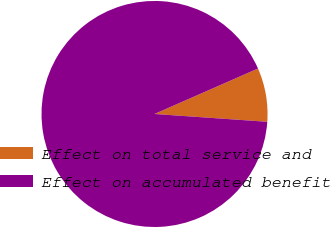<chart> <loc_0><loc_0><loc_500><loc_500><pie_chart><fcel>Effect on total service and<fcel>Effect on accumulated benefit<nl><fcel>7.69%<fcel>92.31%<nl></chart> 